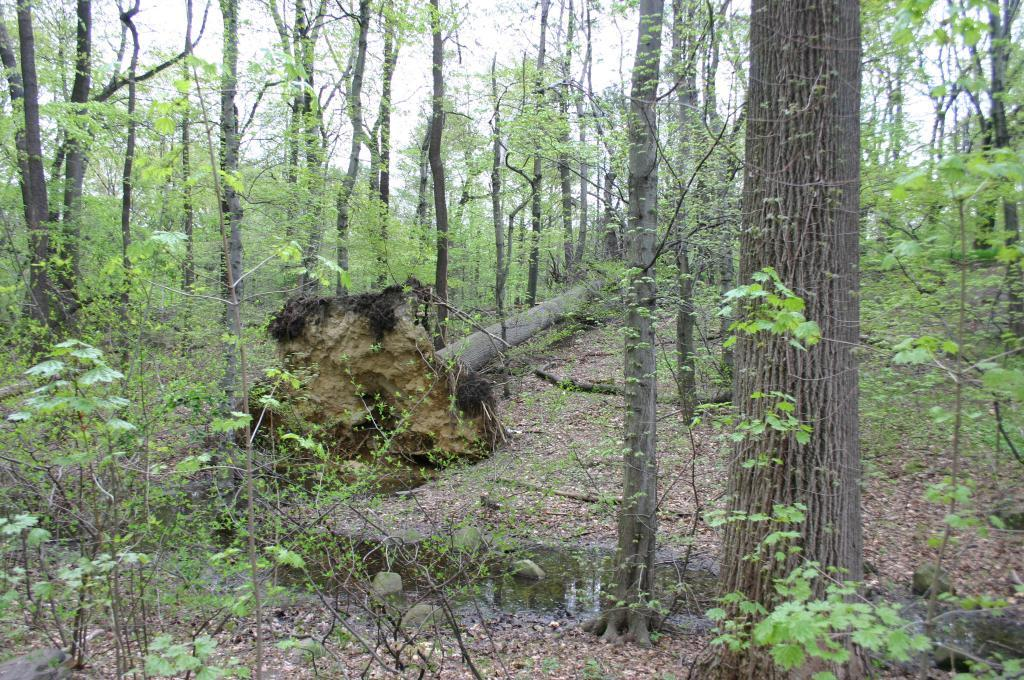What type of vegetation can be seen in the image? There are trees in the image. What natural element is visible in the image? There is water visible in the image. What type of adjustment can be seen being made to the trees in the image? There is no adjustment being made to the trees in the image; they are simply standing. Where might someone go to purchase items related to the water in the image? The image does not show a shop or any indication of where to purchase items related to the water. 